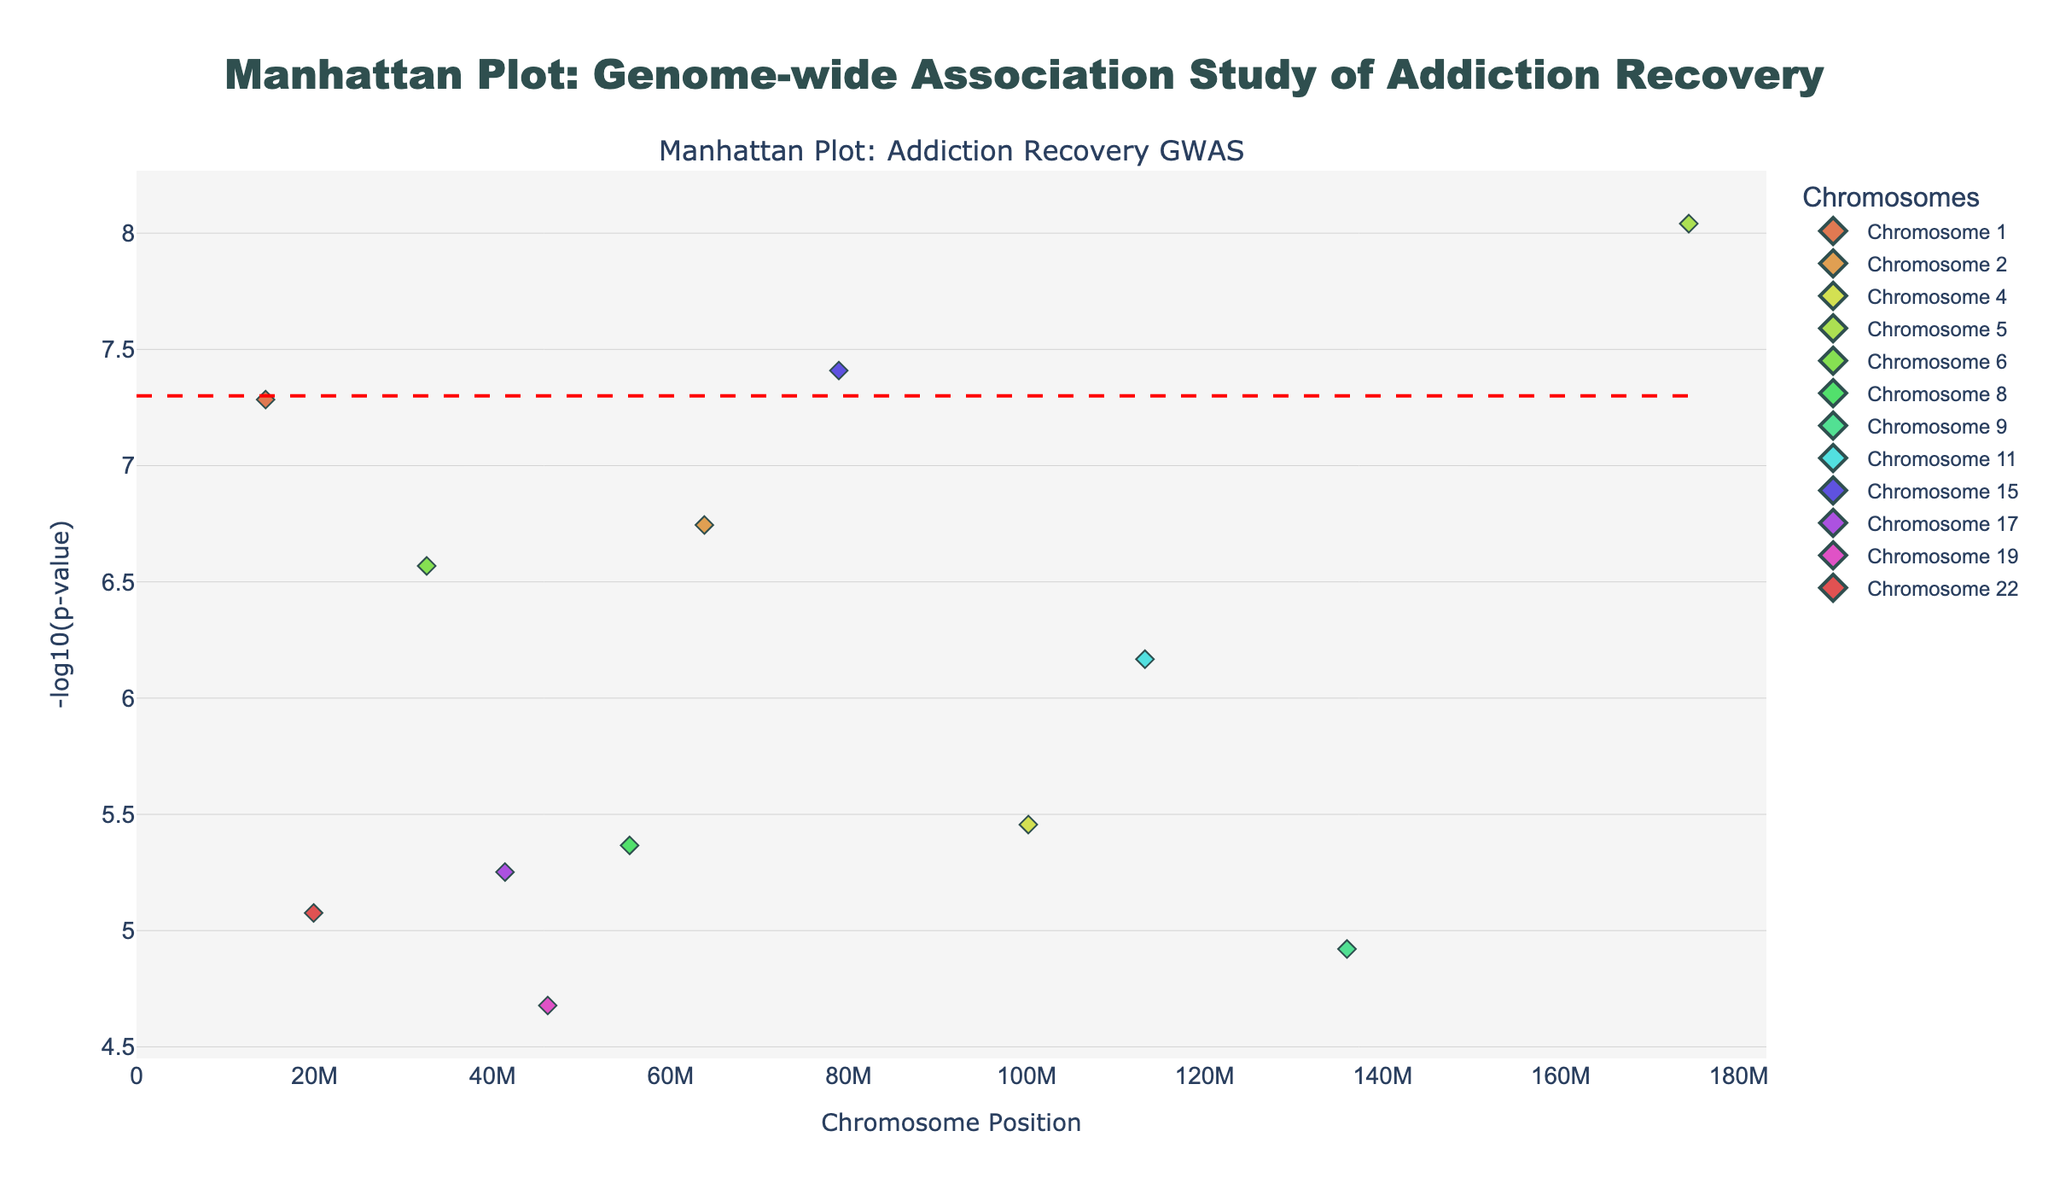What does the title of the plot indicate? The title of the plot is "Manhattan Plot: Genome-wide Association Study of Addiction Recovery". This title indicates that the plot is displaying data from a genomic study aimed at identifying genetic variations associated with the success rates of addiction recovery.
Answer: Genome-wide Association Study of Addiction Recovery What does the y-axis represent? The y-axis represents the -log10(p-value). This transformation is used to make it easier to visualize small p-values, with higher values indicating stronger evidence against the null hypothesis.
Answer: -log10(p-value) Which SNP has the lowest p-value in this study? To find the SNP with the lowest p-value, look for the highest point on the y-axis which corresponds to the smallest p-value. The highest point corresponds to rs16969968 on chromosome 5.
Answer: rs16969968 How many SNPs have -log10(p-values) above the significance threshold of 7.3? To determine the number of SNPs above the significance threshold, count the markers that are plotted above the y-axis value of 7.3. There are three SNPs above this line (rs1229984, rs16969968, and rs2036527).
Answer: 3 Which chromosome has the highest number of significant SNPs above the threshold? Analyze the SNPs above the threshold and determine which chromosome they belong to. Chromosome 5 and Chromosome 15 each have one SNP meeting the threshold, but no chromosome has more than one significant SNP.
Answer: None What is the SNP with the highest p-value on Chromosome 11? To find the SNP with the highest p-value on Chromosome 11, locate the points on Chromosome 11 and identify the one with the -log10(p-value) that is the lowest. This SNP is rs1799732, with a p-value corresponding to a -log10(p-value) of slightly below 7.
Answer: rs1799732 Which chromosomes have SNPs with p-values between 1e-5 and 1e-6? To identify these chromosomes, look for points with -log10(p-values) between 5 and 6. The SNPs with these p-values are found on Chromosomes 9, 17, 19, and 22.
Answer: 9, 17, 19, 22 